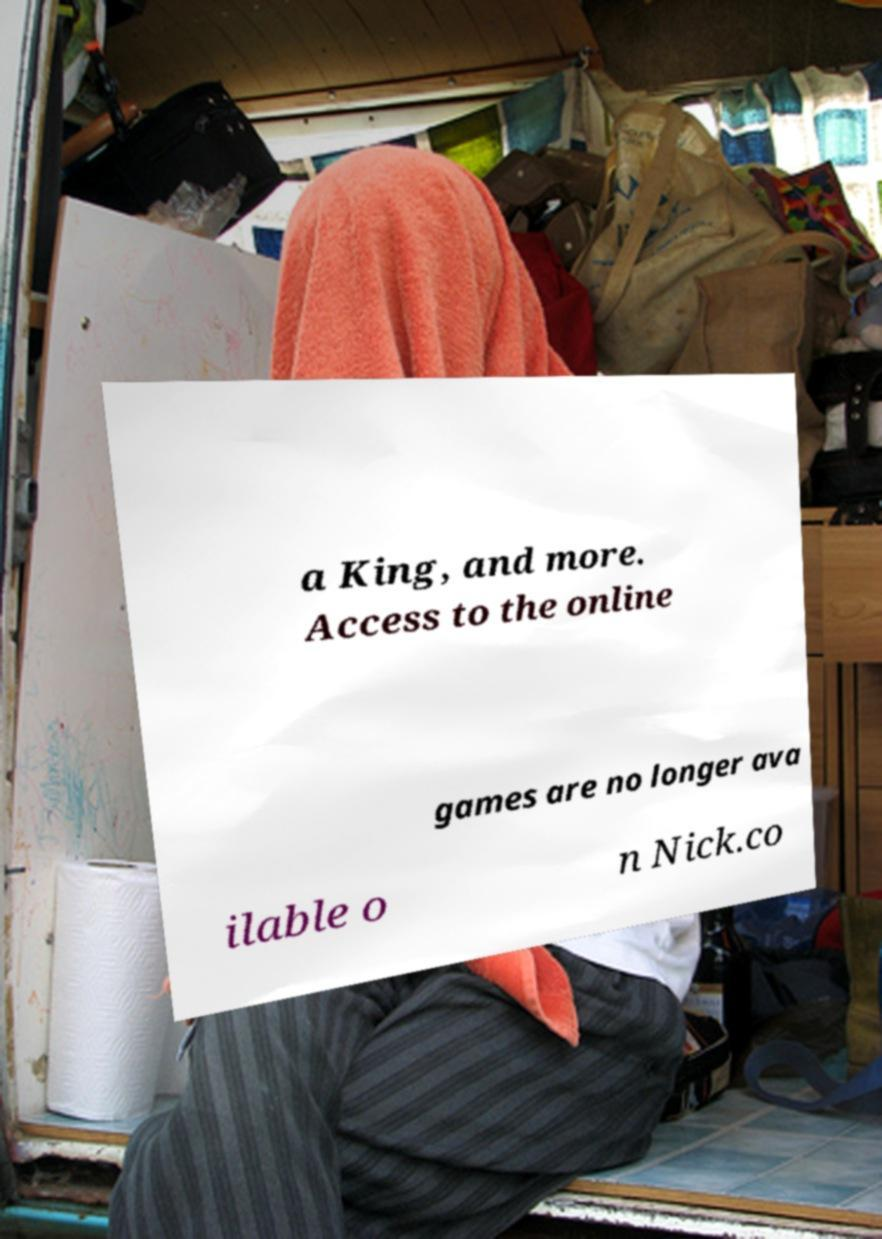What messages or text are displayed in this image? I need them in a readable, typed format. a King, and more. Access to the online games are no longer ava ilable o n Nick.co 